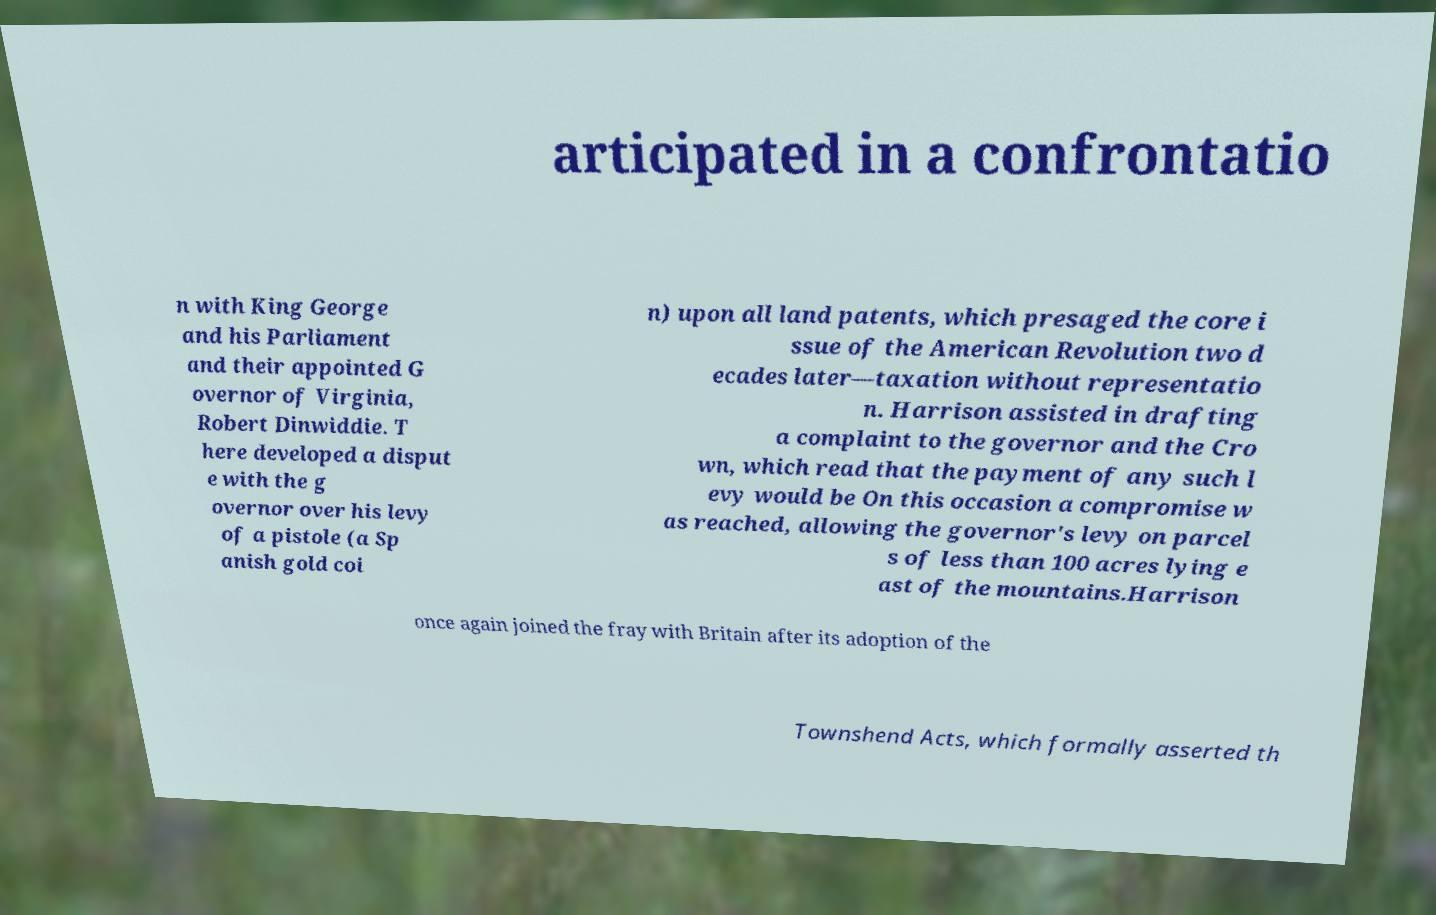Could you assist in decoding the text presented in this image and type it out clearly? articipated in a confrontatio n with King George and his Parliament and their appointed G overnor of Virginia, Robert Dinwiddie. T here developed a disput e with the g overnor over his levy of a pistole (a Sp anish gold coi n) upon all land patents, which presaged the core i ssue of the American Revolution two d ecades later—taxation without representatio n. Harrison assisted in drafting a complaint to the governor and the Cro wn, which read that the payment of any such l evy would be On this occasion a compromise w as reached, allowing the governor's levy on parcel s of less than 100 acres lying e ast of the mountains.Harrison once again joined the fray with Britain after its adoption of the Townshend Acts, which formally asserted th 